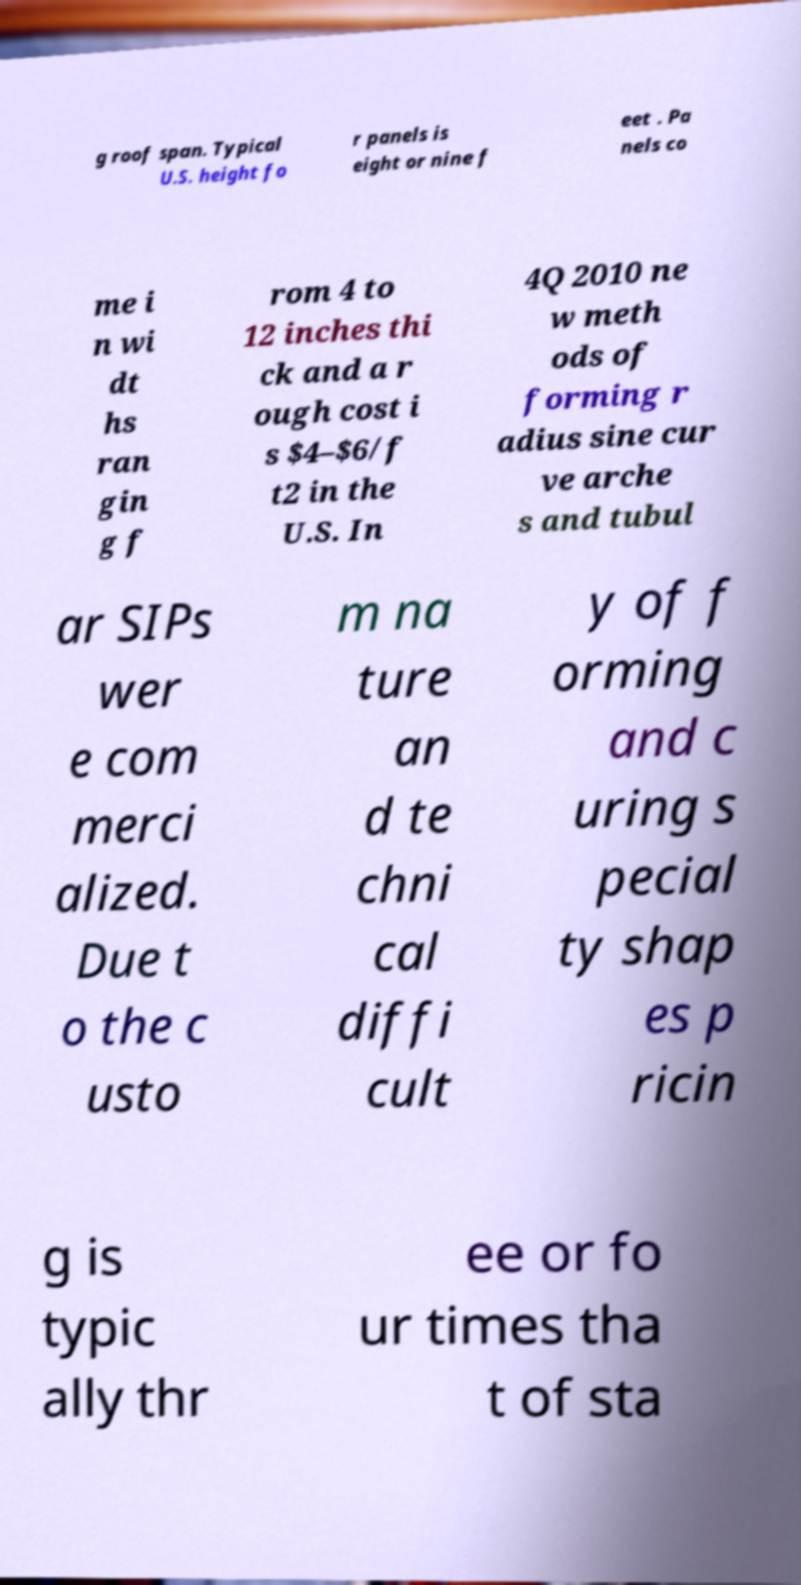What messages or text are displayed in this image? I need them in a readable, typed format. g roof span. Typical U.S. height fo r panels is eight or nine f eet . Pa nels co me i n wi dt hs ran gin g f rom 4 to 12 inches thi ck and a r ough cost i s $4–$6/f t2 in the U.S. In 4Q 2010 ne w meth ods of forming r adius sine cur ve arche s and tubul ar SIPs wer e com merci alized. Due t o the c usto m na ture an d te chni cal diffi cult y of f orming and c uring s pecial ty shap es p ricin g is typic ally thr ee or fo ur times tha t of sta 